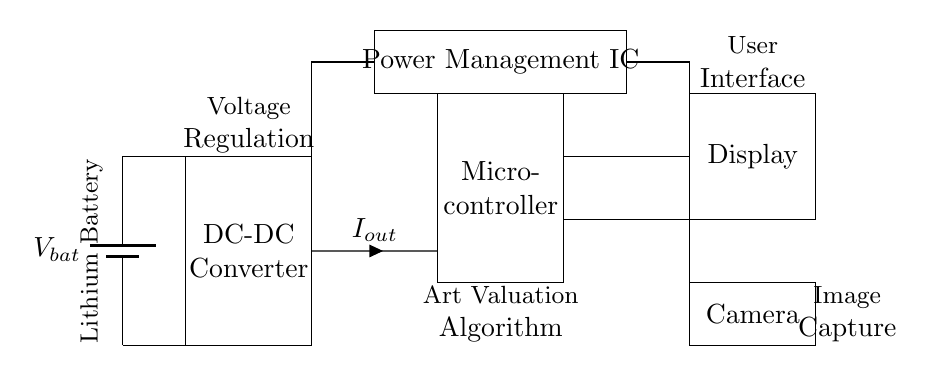What is the power source in this circuit? The power source is a lithium battery, which is indicated in the diagram by the labeled battery symbol.
Answer: Lithium battery What component is responsible for voltage regulation? The voltage regulation is handled by the DC-DC converter, which is clearly marked in the diagram as a rectangle with the label "DC-DC Converter."
Answer: DC-DC Converter How is the camera powered in this circuit? The camera receives power from the output of the DC-DC converter, as indicated by the connection labeled 'I out' which feeds into the microcontroller and subsequently leads to the camera.
Answer: Through the DC-DC converter Which component is responsible for the user interface? The user interface is represented by the "Display" component in the circuit, which is shown as a rectangle labeled "Display."
Answer: Display What is the function of the Power Management IC in this diagram? The Power Management IC manages the power distribution from the battery to the other components, ensuring that the required voltages are supplied to the microcontroller and display. It is connected to both the battery and the display, indicating its role in power control.
Answer: Power distribution What does the microcontroller connect to directly in this circuit? The microcontroller directly connects to the output of the DC-DC converter, receiving power to operate the art valuation algorithm, and it also connects to the display for user interaction.
Answer: DC-DC Converter How many main functional blocks are presented in the circuit? The circuit includes four main functional blocks: the battery, DC-DC converter, microcontroller, and display/camera components. This shows the key functional relationships necessary for the portable art valuation device.
Answer: Four 